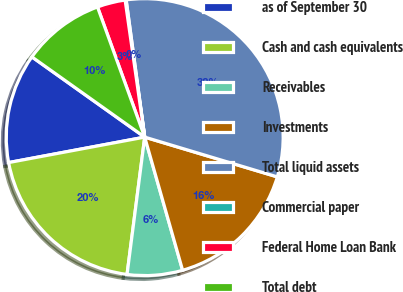<chart> <loc_0><loc_0><loc_500><loc_500><pie_chart><fcel>as of September 30<fcel>Cash and cash equivalents<fcel>Receivables<fcel>Investments<fcel>Total liquid assets<fcel>Commercial paper<fcel>Federal Home Loan Bank<fcel>Total debt<nl><fcel>12.78%<fcel>20.02%<fcel>6.45%<fcel>15.95%<fcel>31.78%<fcel>0.12%<fcel>3.28%<fcel>9.62%<nl></chart> 